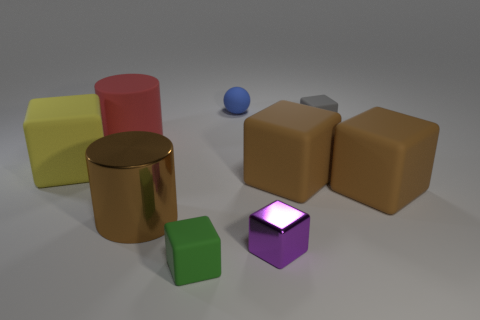Subtract all brown blocks. How many blocks are left? 4 Subtract all gray blocks. How many blocks are left? 5 Subtract all cyan cubes. Subtract all gray spheres. How many cubes are left? 6 Add 1 big cyan shiny objects. How many objects exist? 10 Subtract all cubes. How many objects are left? 3 Subtract all small metal blocks. Subtract all gray cubes. How many objects are left? 7 Add 8 tiny purple shiny blocks. How many tiny purple shiny blocks are left? 9 Add 9 tiny gray rubber objects. How many tiny gray rubber objects exist? 10 Subtract 0 blue cubes. How many objects are left? 9 